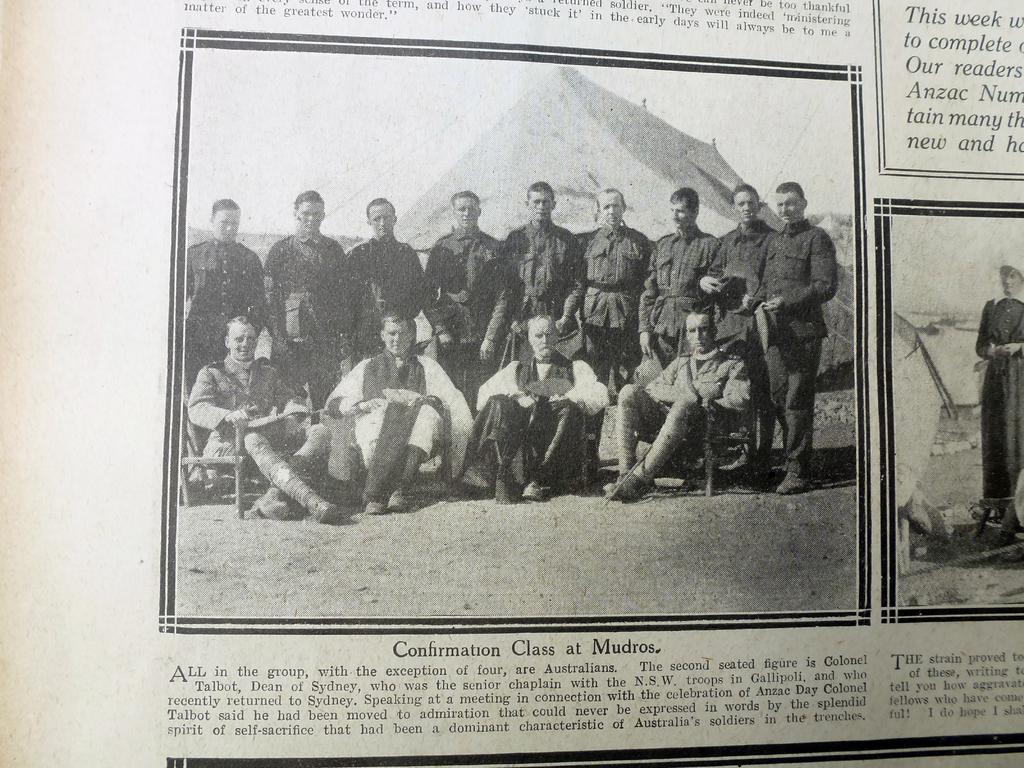Describe this image in one or two sentences. In this image, we can see an article. Here we can see two pictures. In these pictures, we can see people. 